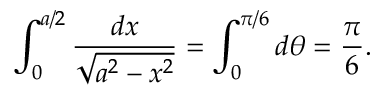Convert formula to latex. <formula><loc_0><loc_0><loc_500><loc_500>\int _ { 0 } ^ { a / 2 } { \frac { d x } { \sqrt { a ^ { 2 } - x ^ { 2 } } } } = \int _ { 0 } ^ { \pi / 6 } d \theta = { \frac { \pi } { 6 } } .</formula> 